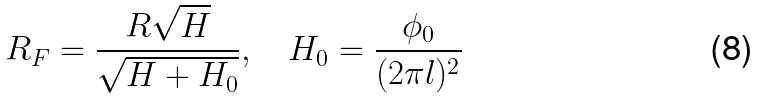<formula> <loc_0><loc_0><loc_500><loc_500>R _ { F } = \frac { R \sqrt { H } } { \sqrt { H + H _ { 0 } } } , \quad H _ { 0 } = \frac { \phi _ { 0 } } { ( 2 \pi l ) ^ { 2 } }</formula> 